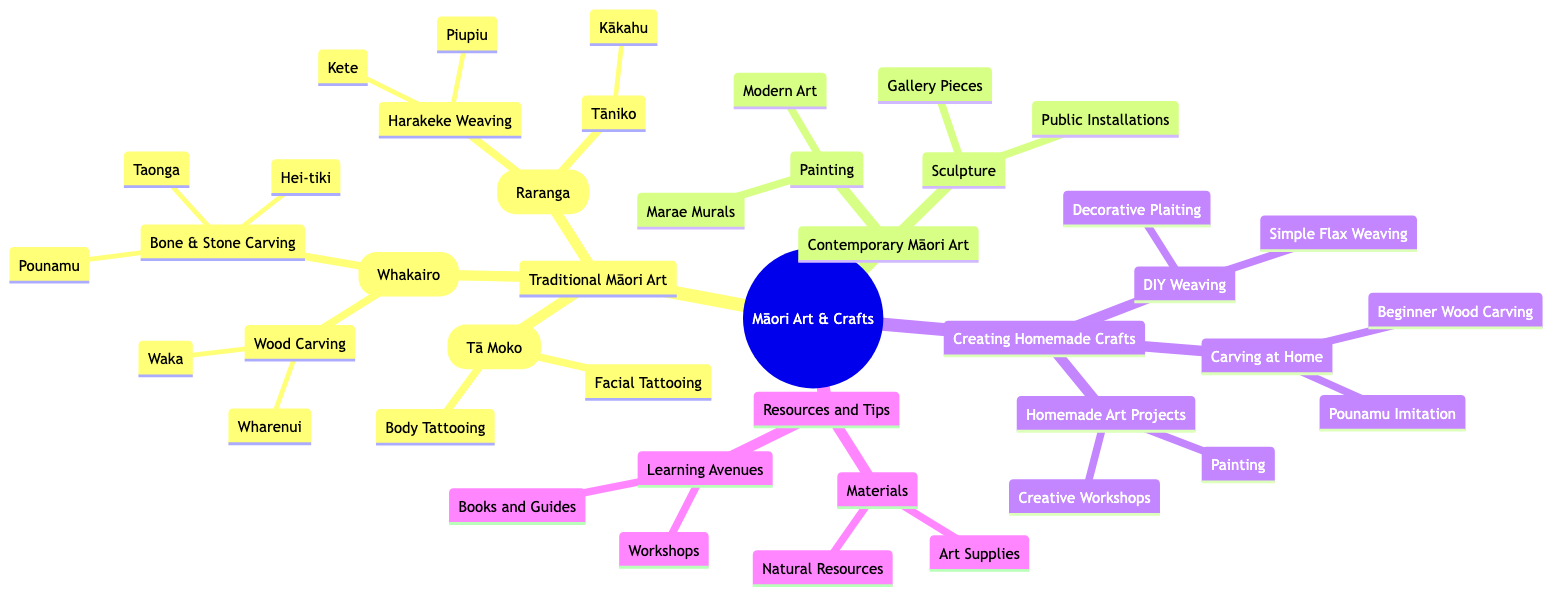What are the two main categories of Māori art forms? The diagram lists "Traditional Māori Art" and "Contemporary Māori Art" as the two main categories under "Exploring Māori Art Forms and Creating Homemade Crafts."
Answer: Traditional Māori Art, Contemporary Māori Art How many types of traditional Māori art are represented in the diagram? Under "Traditional Māori Art," there are three types: "Carving (Whakairo)," "Weaving (Raranga)," and "Tattooing (Tā Moko)." Thus, the number is three.
Answer: 3 What type of weaving is made from harakeke? The diagram indicates that "Harakeke (flax) Weaving" includes making "Kete (baskets)" and "Piupiu (skirts)." The specific type asked for is "Harakeke (flax) Weaving."
Answer: Harakeke (flax) Weaving Which Māori art form includes "Public Installations"? Looking at the "Contemporary Māori Art" section under "Sculpture," it is stated that "Public Installations" celebrate Māori heritage in urban spaces. Thus, the answer is found there.
Answer: Sculpture What materials are mentioned as part of the resources for creating crafts? The "Materials" section lists "Natural Resources" such as flax, wood, and stones, as well as "Art Supplies" like paints, brushes, and carving tools. Thus, a summary is "Natural Resources, Art Supplies."
Answer: Natural Resources, Art Supplies Which type of crafting has two specific categories mentioned? In the "Creating Homemade Crafts" section, "DIY Weaving" has two specific categories: "Simple Flax Weaving" and "Decorative Plaiting." This indicates it as the crafting type with two categories.
Answer: DIY Weaving What is one of the examples listed under "Beginner Wood Carving"? The diagram mentions that "Beginner Wood Carving" involves "Starting with simple shapes and patterns," thus providing clarity on what that entails.
Answer: Starting with simple shapes and patterns How many nodes are there in the "Traditional Māori Art" section? In the "Traditional Māori Art" section, there are three main categories: "Carving (Whakairo)," "Weaving (Raranga)," and "Tattooing (Tā Moko)." Under "Carving," there are two nodes (Wood and Bone & Stone Carving), under "Weaving," there are two nodes (Harakeke and Tāniko), and under "Tattooing," there are two nodes (Facial and Body Tattooing). Thus, the total is 3 + 2 + 2 + 2 = 9.
Answer: 9 